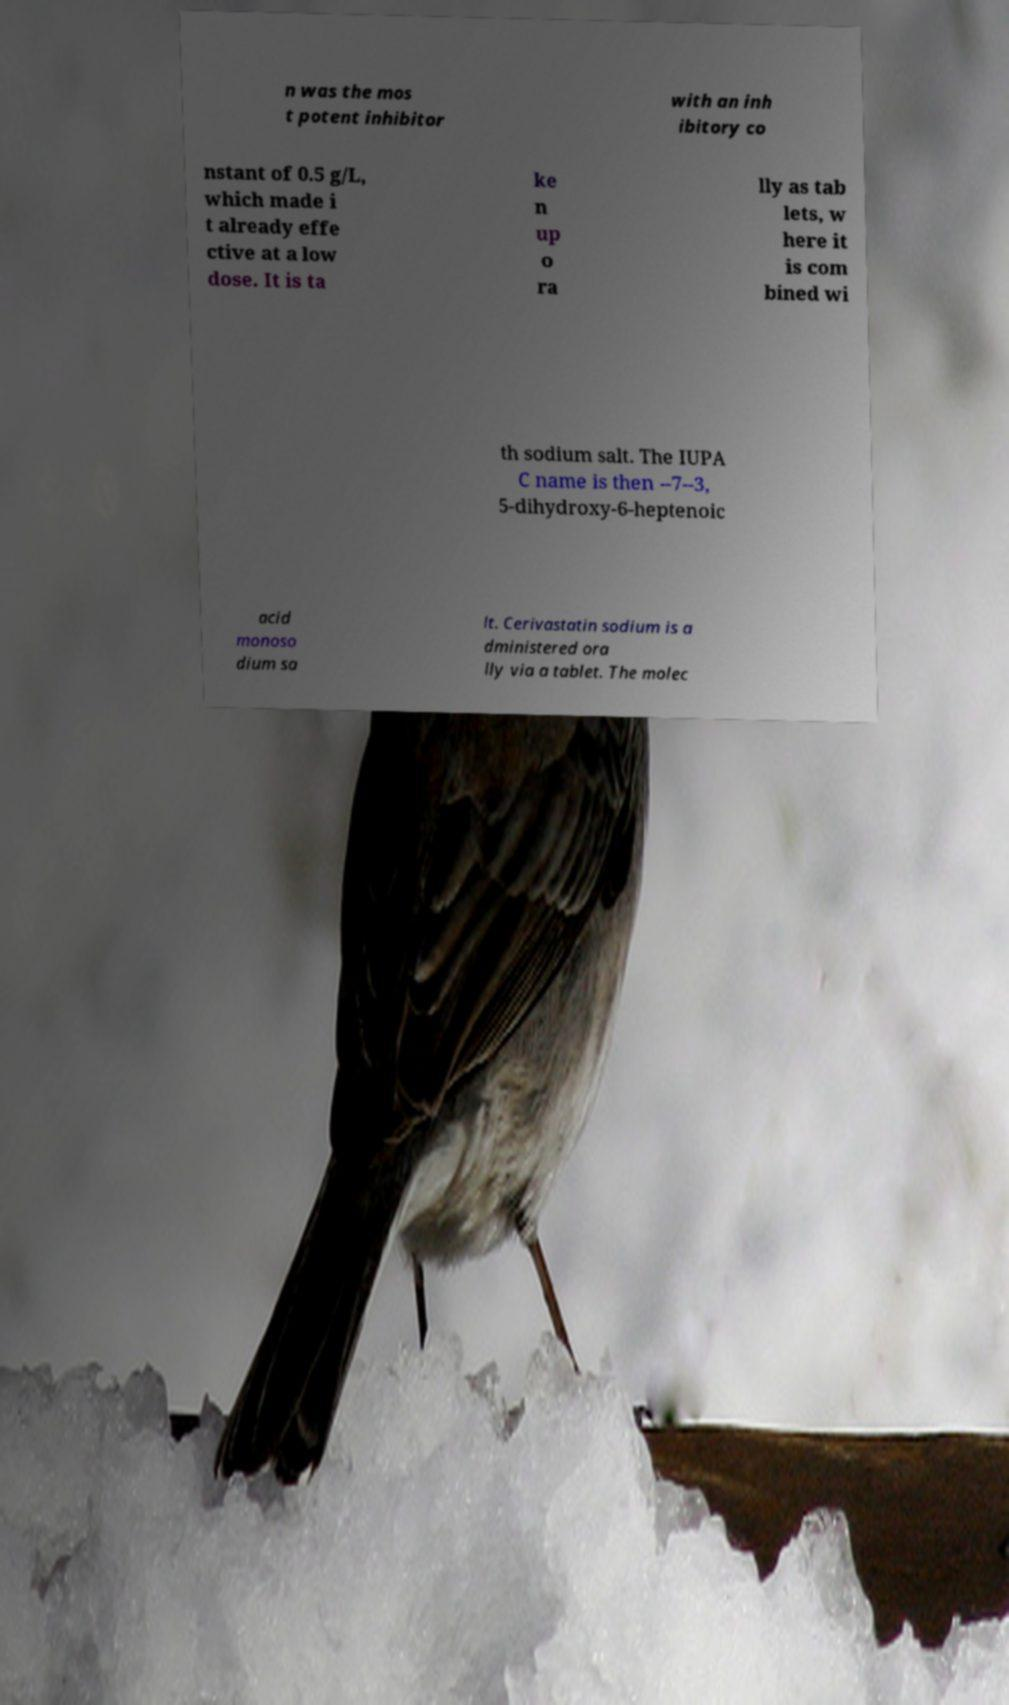Please identify and transcribe the text found in this image. n was the mos t potent inhibitor with an inh ibitory co nstant of 0.5 g/L, which made i t already effe ctive at a low dose. It is ta ke n up o ra lly as tab lets, w here it is com bined wi th sodium salt. The IUPA C name is then --7--3, 5-dihydroxy-6-heptenoic acid monoso dium sa lt. Cerivastatin sodium is a dministered ora lly via a tablet. The molec 